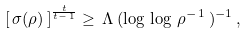Convert formula to latex. <formula><loc_0><loc_0><loc_500><loc_500>\left [ \, \sigma ( \rho ) \, \right ] ^ { \frac { t } { t - \, 1 } } \geq \, \Lambda \, ( \log \, \log \, \rho ^ { - \, 1 } \, ) ^ { - 1 } \, ,</formula> 